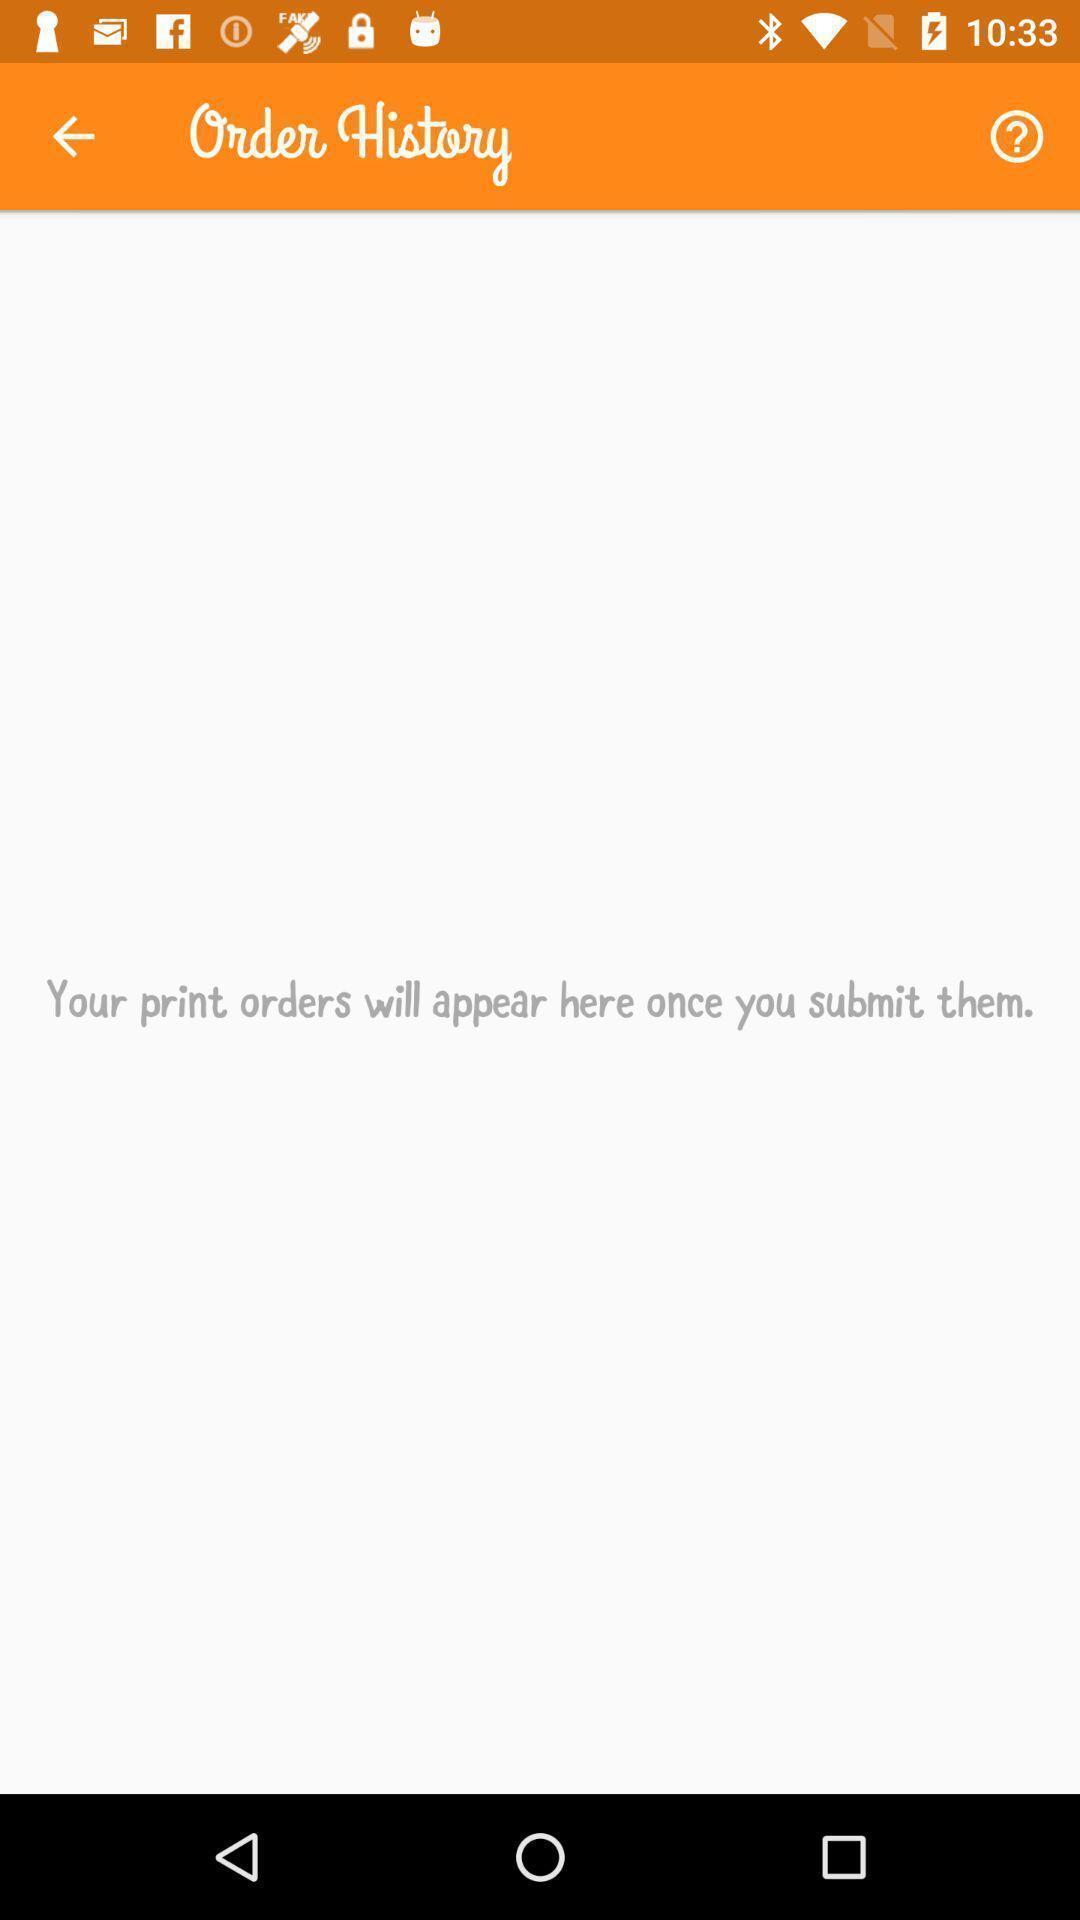Please provide a description for this image. Page showing order history. 